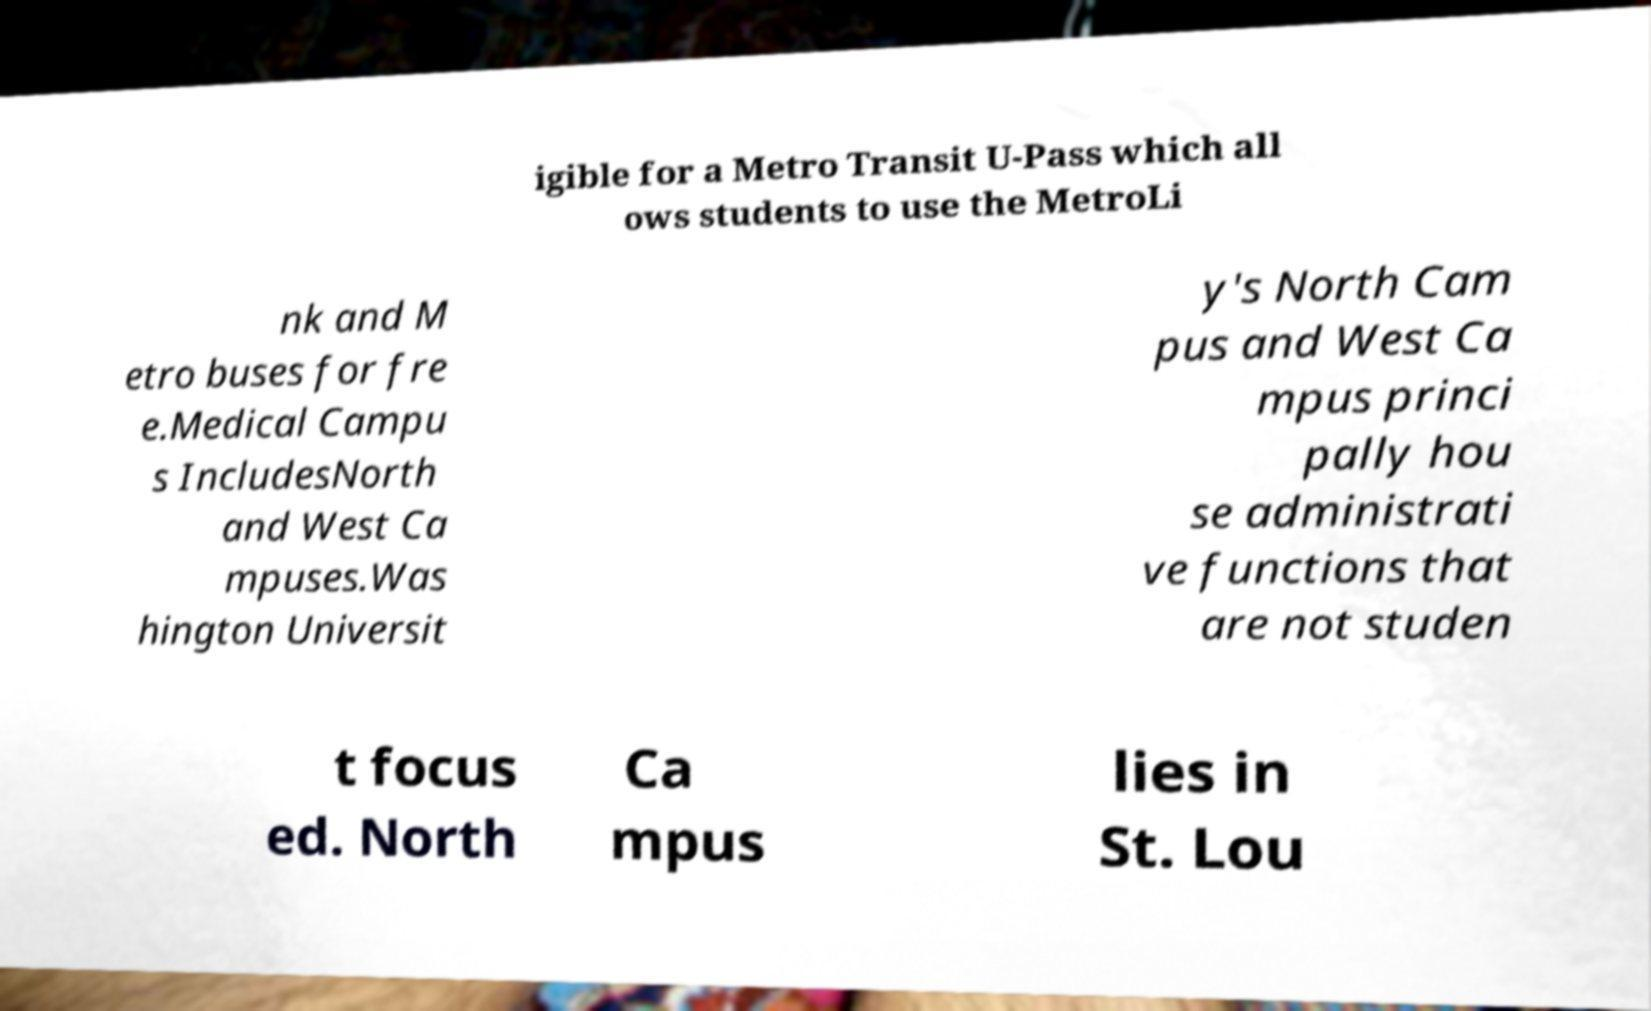For documentation purposes, I need the text within this image transcribed. Could you provide that? igible for a Metro Transit U-Pass which all ows students to use the MetroLi nk and M etro buses for fre e.Medical Campu s IncludesNorth and West Ca mpuses.Was hington Universit y's North Cam pus and West Ca mpus princi pally hou se administrati ve functions that are not studen t focus ed. North Ca mpus lies in St. Lou 